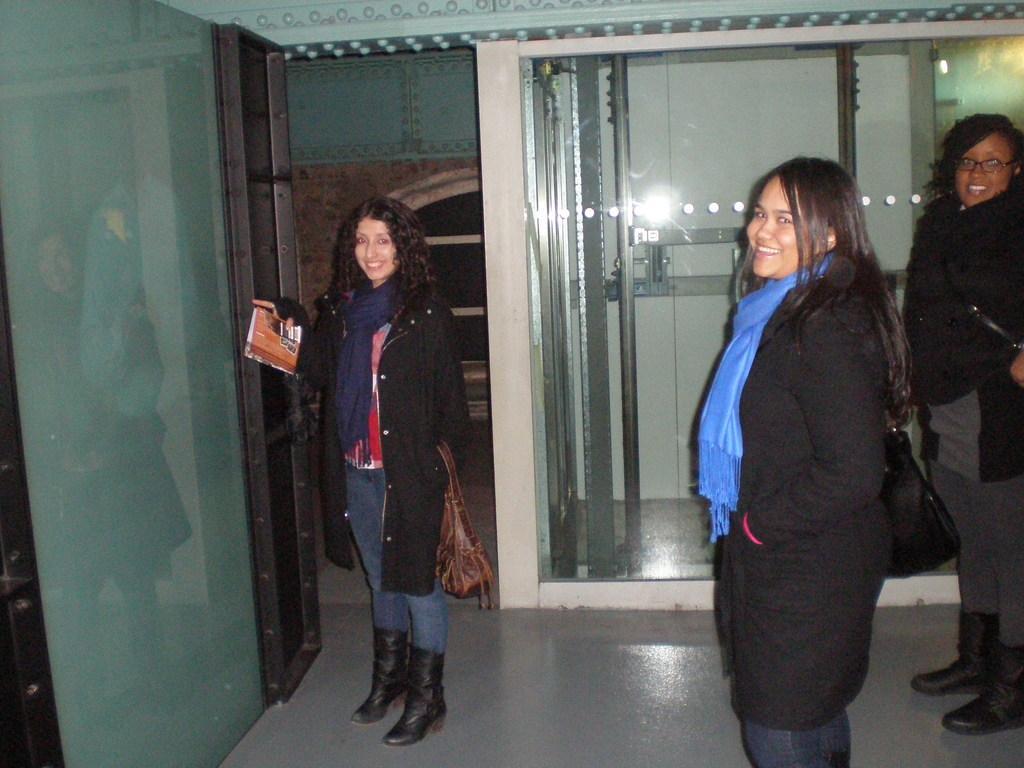Could you give a brief overview of what you see in this image? In this picture we can see three woman, they are standing and smiling, the left side person is holding a paper, and also we can find few glass doors. 